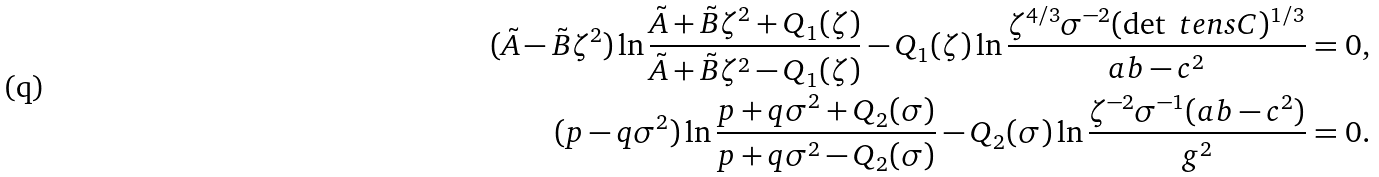Convert formula to latex. <formula><loc_0><loc_0><loc_500><loc_500>( \tilde { A } - \tilde { B } \zeta ^ { 2 } ) \ln \frac { \tilde { A } + \tilde { B } \zeta ^ { 2 } + Q _ { 1 } ( \zeta ) } { \tilde { A } + \tilde { B } \zeta ^ { 2 } - Q _ { 1 } ( \zeta ) } - Q _ { 1 } ( \zeta ) \ln \frac { \zeta ^ { 4 / 3 } \sigma ^ { - 2 } ( \det \ t e n s { C } ) ^ { 1 / 3 } } { a b - c ^ { 2 } } = 0 , \\ ( p - q \sigma ^ { 2 } ) \ln \frac { p + q \sigma ^ { 2 } + Q _ { 2 } ( \sigma ) } { p + q \sigma ^ { 2 } - Q _ { 2 } ( \sigma ) } - Q _ { 2 } ( \sigma ) \ln \frac { \zeta ^ { - 2 } \sigma ^ { - 1 } ( a b - c ^ { 2 } ) } { g ^ { 2 } } = 0 .</formula> 